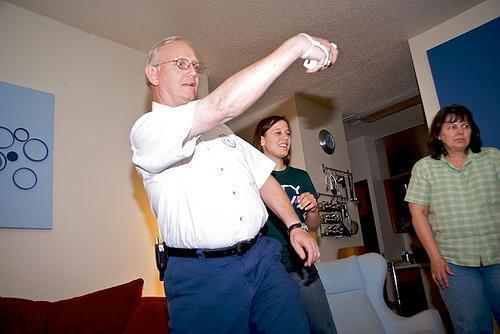How many people are there?
Give a very brief answer. 3. 